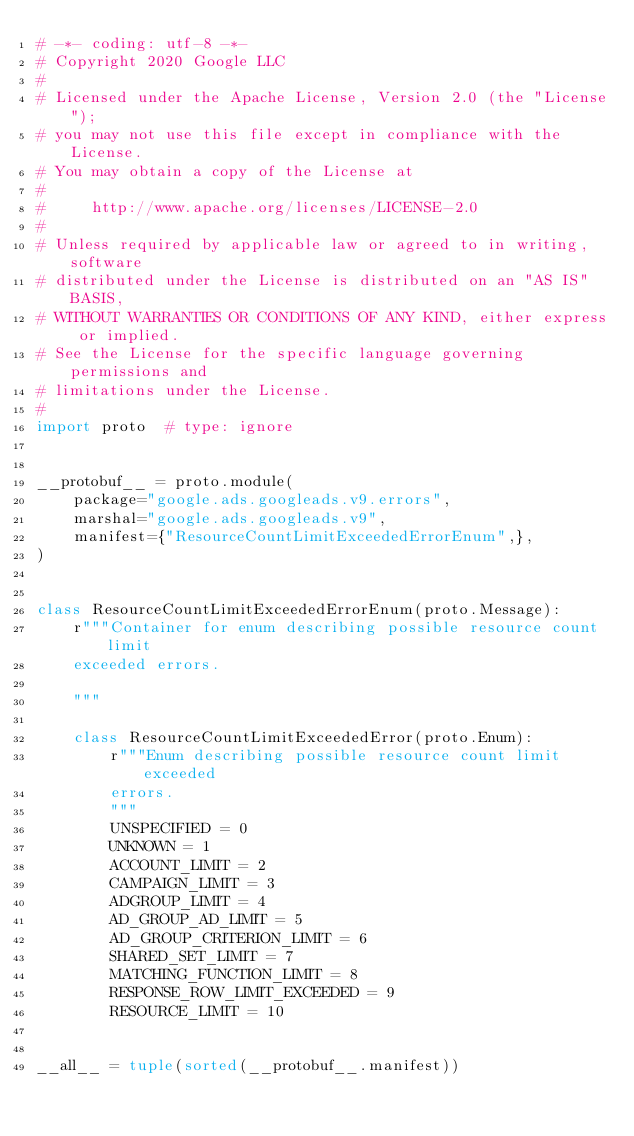Convert code to text. <code><loc_0><loc_0><loc_500><loc_500><_Python_># -*- coding: utf-8 -*-
# Copyright 2020 Google LLC
#
# Licensed under the Apache License, Version 2.0 (the "License");
# you may not use this file except in compliance with the License.
# You may obtain a copy of the License at
#
#     http://www.apache.org/licenses/LICENSE-2.0
#
# Unless required by applicable law or agreed to in writing, software
# distributed under the License is distributed on an "AS IS" BASIS,
# WITHOUT WARRANTIES OR CONDITIONS OF ANY KIND, either express or implied.
# See the License for the specific language governing permissions and
# limitations under the License.
#
import proto  # type: ignore


__protobuf__ = proto.module(
    package="google.ads.googleads.v9.errors",
    marshal="google.ads.googleads.v9",
    manifest={"ResourceCountLimitExceededErrorEnum",},
)


class ResourceCountLimitExceededErrorEnum(proto.Message):
    r"""Container for enum describing possible resource count limit
    exceeded errors.

    """

    class ResourceCountLimitExceededError(proto.Enum):
        r"""Enum describing possible resource count limit exceeded
        errors.
        """
        UNSPECIFIED = 0
        UNKNOWN = 1
        ACCOUNT_LIMIT = 2
        CAMPAIGN_LIMIT = 3
        ADGROUP_LIMIT = 4
        AD_GROUP_AD_LIMIT = 5
        AD_GROUP_CRITERION_LIMIT = 6
        SHARED_SET_LIMIT = 7
        MATCHING_FUNCTION_LIMIT = 8
        RESPONSE_ROW_LIMIT_EXCEEDED = 9
        RESOURCE_LIMIT = 10


__all__ = tuple(sorted(__protobuf__.manifest))
</code> 